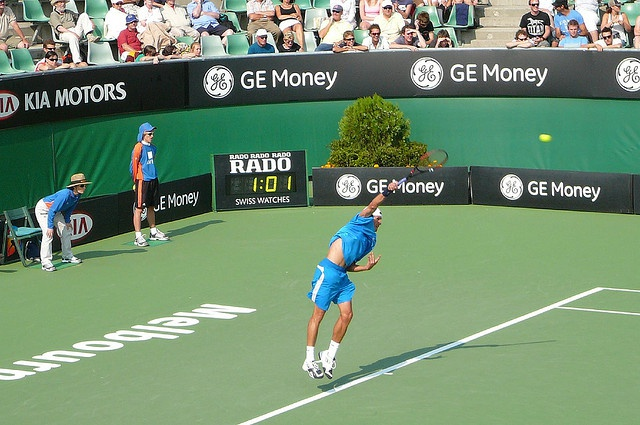Describe the objects in this image and their specific colors. I can see people in darkgray, white, black, and tan tones, people in darkgray, lightblue, white, blue, and tan tones, people in darkgray, black, white, lightblue, and salmon tones, people in darkgray, white, lightblue, and gray tones, and people in darkgray, white, gray, and tan tones in this image. 